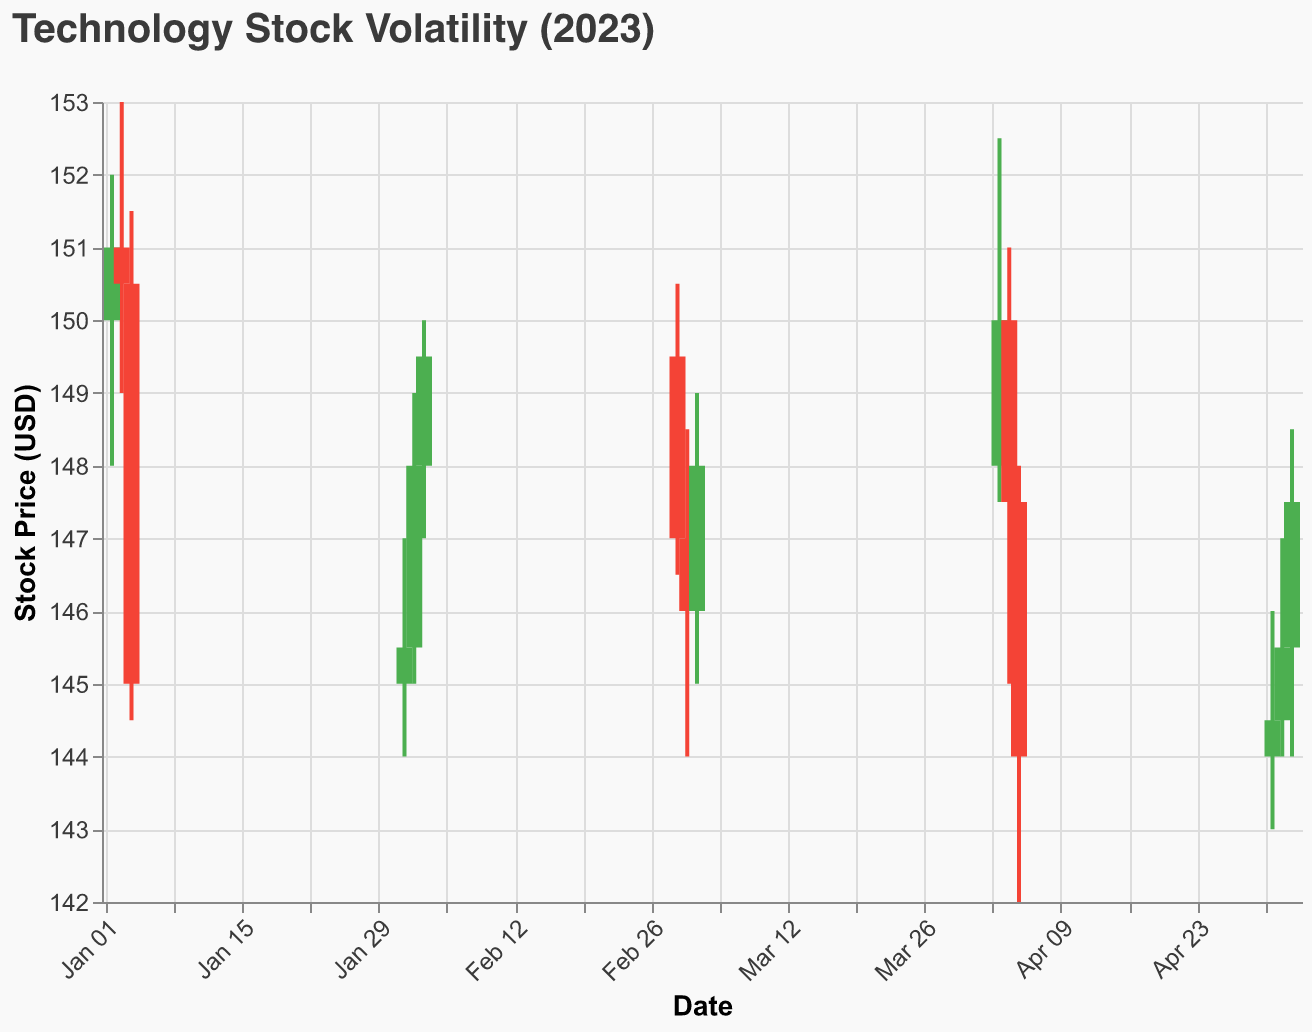Which date shows the highest stock price? The highest price is shown in the "High" field for each date. Observing the "High" values, January 3rd has the highest value of 153.00 USD.
Answer: January 3rd What is the opening price on February 3rd? To find this information, refer to the "Open" field for the given date. The opening price on February 3rd is 148.00 USD.
Answer: 148.00 USD Which date has the lowest closing price? The closing prices are shown in the "Close" field for each date. By comparing these values, January 4th has the lowest closing price of 145.00 USD.
Answer: January 4th How many data points are represented in the figure? Each row in the data set represents a data point. Counting the rows, there are 15 data points in the figure.
Answer: 15 What is the average closing price for the dates in March? Find the "Close" values for March 1st, 2nd, and 3rd: 147.00, 146.00, and 148.00 USD. Sum these values to get 441.00 USD, then divide by 3 (number of data points) to get the average. 441.00 / 3 = 147.00 USD.
Answer: 147.00 USD Which date has the highest trading volume, and what is the value? The trading volumes are listed under the "Volume" field. The highest volume is on January 4th with 1,400,000 shares traded.
Answer: January 4th, 1,400,000 Compare the opening prices between January 2nd and April 3rd. Which is higher and by how much? The opening price on January 2nd is 150.00 USD and on April 3rd is 148.00 USD. January 2nd's opening price is higher by 150.00 - 148.00 = 2.00 USD.
Answer: January 2nd, 2.00 USD Which month had the most days where the closing price was higher than the opening price? Identify green bars where the "Close" price is higher than the "Open" price for each month. January has two days (2nd, 3rd) and May has two days (1st, 3rd). Both months tie with 2 days each.
Answer: January and May What is the price range (difference between High and Low) on April 5th? Subtract the "Low" value from the "High" value for April 5th. The high is 148.00 USD and the low is 142.00 USD, so the range is 148.00 - 142.00 = 6.00 USD.
Answer: 6.00 USD By how much did the closing price change from February 2nd to February 3rd? Check the "Close" prices for the two dates: February 2nd is 148.00 USD and February 3rd is 149.50 USD. The change is 149.50 - 148.00 = 1.50 USD.
Answer: 1.50 USD 